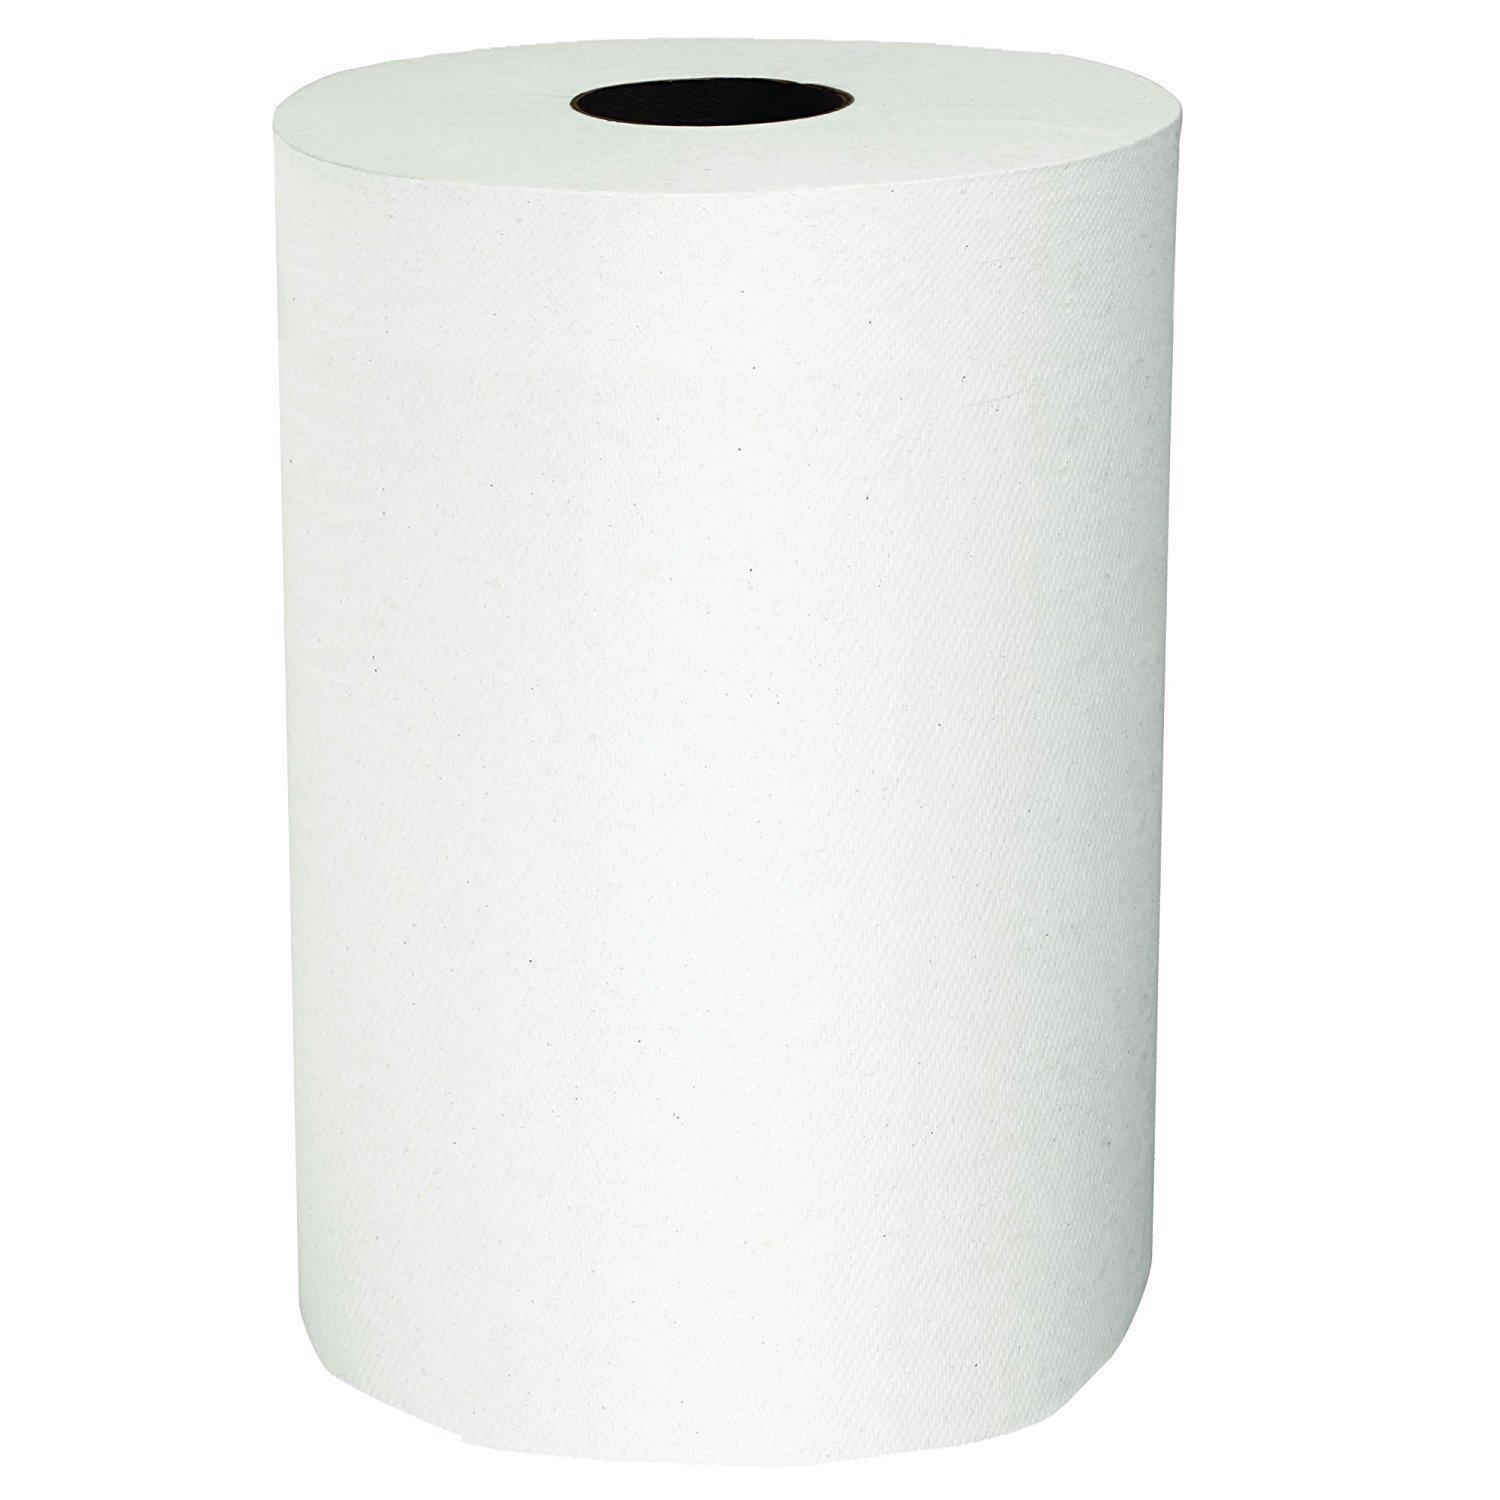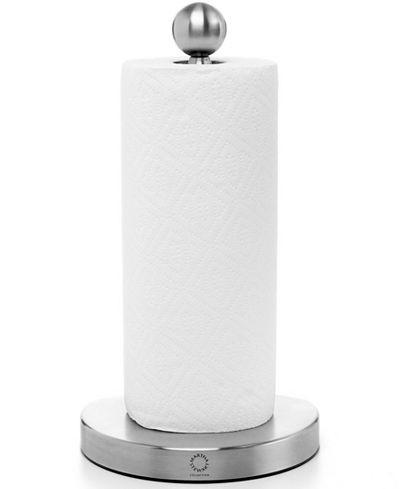The first image is the image on the left, the second image is the image on the right. For the images displayed, is the sentence "One of the images show some type of paper towel dispenser." factually correct? Answer yes or no. Yes. The first image is the image on the left, the second image is the image on the right. Considering the images on both sides, is "An image shows a roll of towels on an upright stand with a chrome part that extends out of the top." valid? Answer yes or no. Yes. 